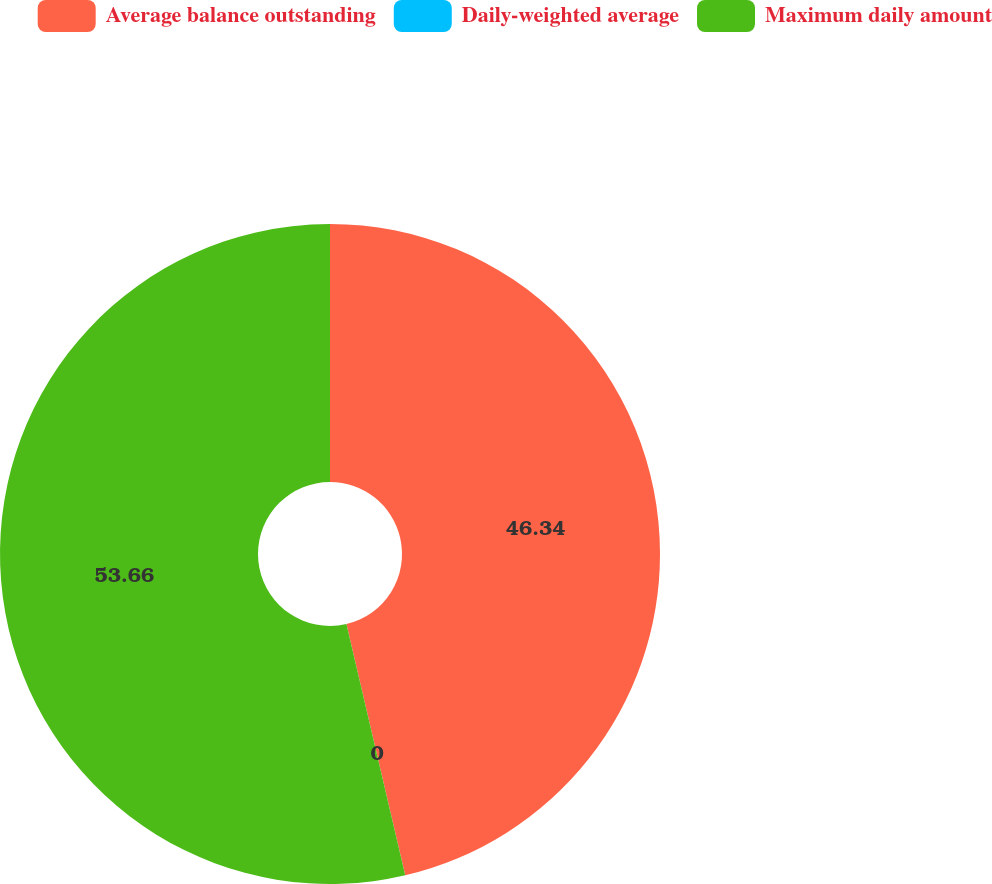Convert chart. <chart><loc_0><loc_0><loc_500><loc_500><pie_chart><fcel>Average balance outstanding<fcel>Daily-weighted average<fcel>Maximum daily amount<nl><fcel>46.34%<fcel>0.0%<fcel>53.66%<nl></chart> 